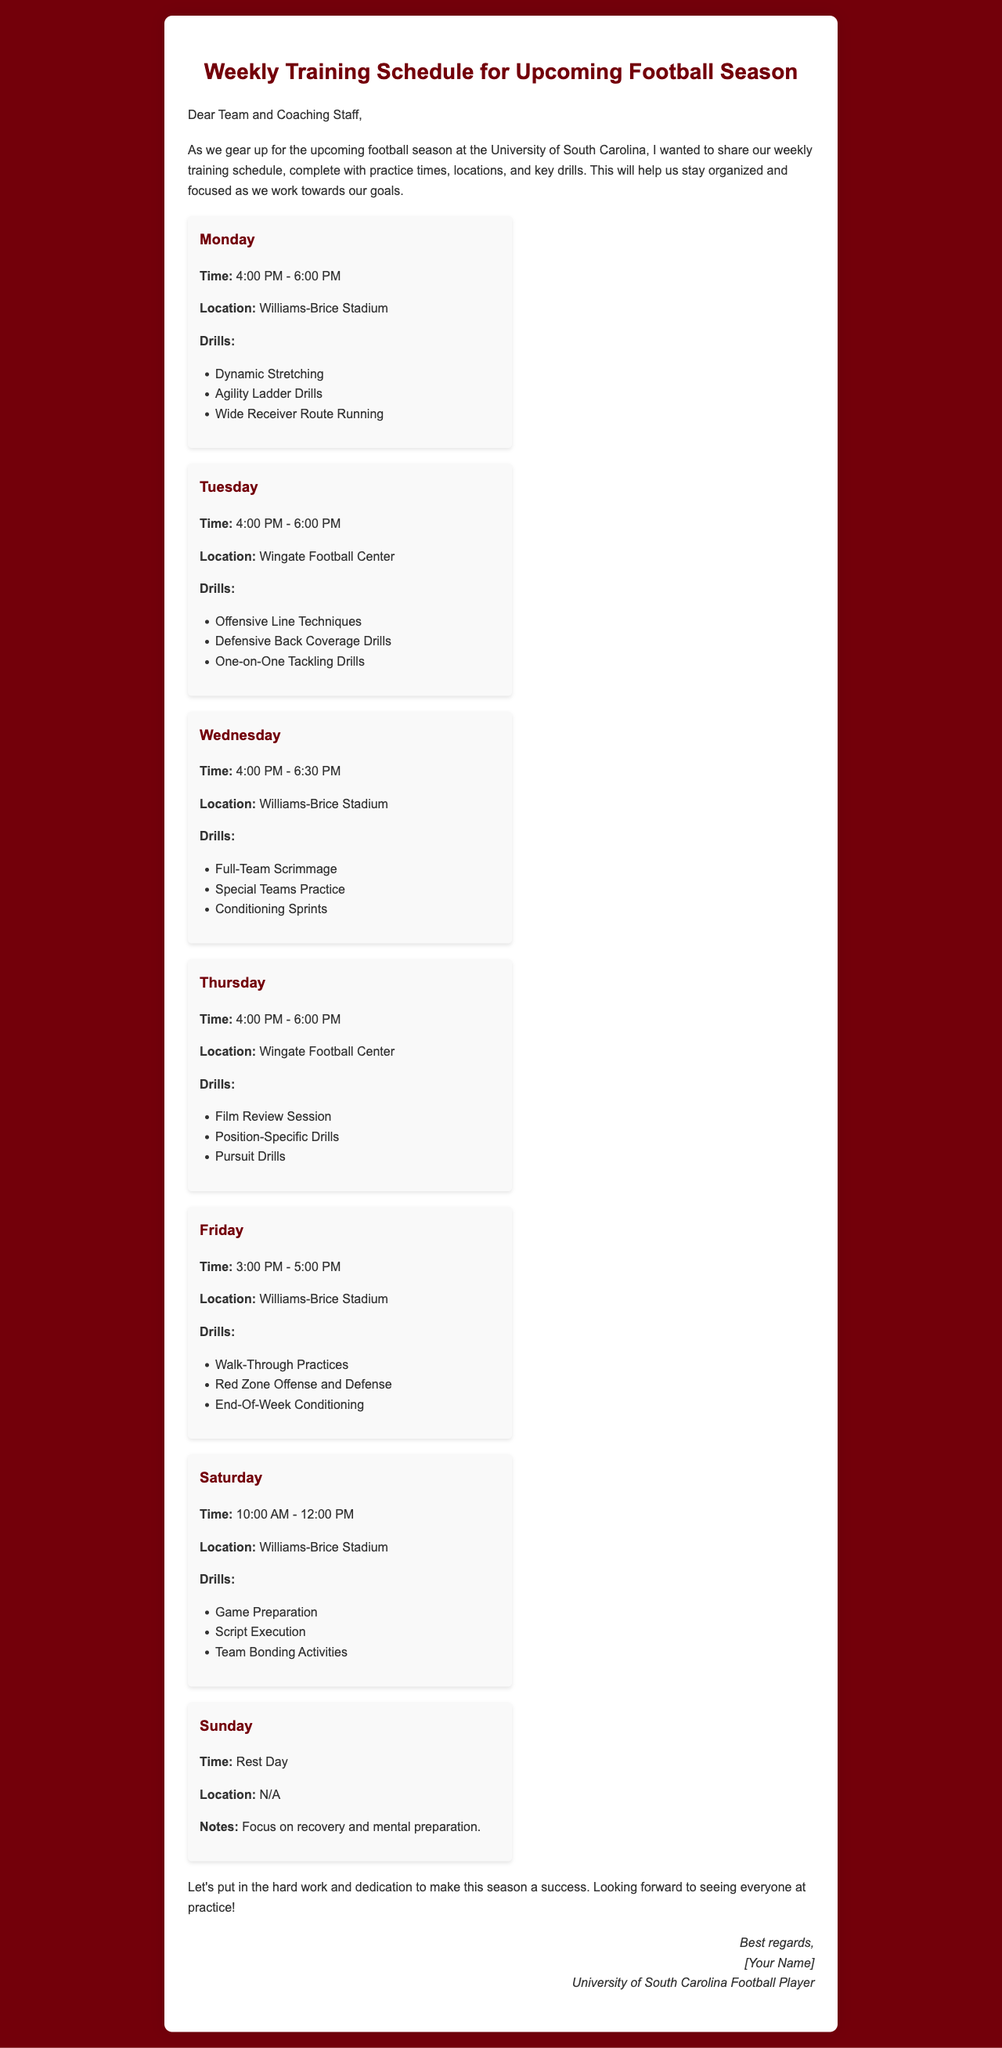What time does practice start on Monday? Monday's practice is scheduled to start at 4:00 PM as mentioned in the schedule.
Answer: 4:00 PM Where is Tuesday's practice located? The location for Tuesday's practice is specified as the Wingate Football Center.
Answer: Wingate Football Center What are the key drills on Wednesday? Wednesday's drills include Full-Team Scrimmage, Special Teams Practice, and Conditioning Sprints, as detailed in the document.
Answer: Full-Team Scrimmage, Special Teams Practice, Conditioning Sprints How long is Friday's practice? Friday's practice time is from 3:00 PM to 5:00 PM, making it a total of 2 hours long.
Answer: 2 hours When is the rest day? The rest day is indicated for Sunday in the schedule provided.
Answer: Sunday What overarching goal is mentioned in the introduction? The introduction emphasizes the goal of staying organized and focused as the team works towards success in the upcoming season.
Answer: Success What is the final activity scheduled for Saturday? Saturday's final scheduled activity focuses on Team Bonding Activities, as noted in the practice schedule.
Answer: Team Bonding Activities How should players prepare on Sunday? Players are advised to focus on recovery and mental preparation for Sunday, as per the notes listed in the document.
Answer: Recovery and mental preparation What color scheme is used for the document? The document uses a color scheme centered around dark red and white throughout its design.
Answer: Dark red and white 